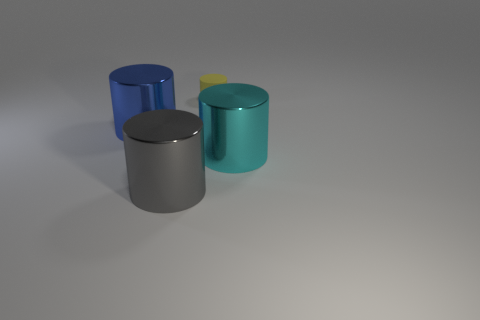Is there anything else that is the same size as the yellow rubber cylinder?
Keep it short and to the point. No. The thing that is behind the large blue cylinder to the left of the big shiny cylinder that is on the right side of the yellow rubber thing is made of what material?
Provide a short and direct response. Rubber. What material is the big blue cylinder?
Your response must be concise. Metal. Are the cyan cylinder and the yellow cylinder that is behind the large gray metallic thing made of the same material?
Your answer should be compact. No. What is the color of the metallic cylinder that is to the right of the cylinder behind the blue metallic cylinder?
Offer a terse response. Cyan. How big is the thing that is both in front of the blue metallic object and left of the small rubber thing?
Make the answer very short. Large. What number of other objects are the same shape as the gray object?
Offer a very short reply. 3. Do the gray shiny thing and the object that is behind the blue metallic cylinder have the same shape?
Give a very brief answer. Yes. There is a cyan metal cylinder; what number of large blue objects are right of it?
Your response must be concise. 0. Are there any other things that are the same material as the yellow thing?
Offer a very short reply. No. 